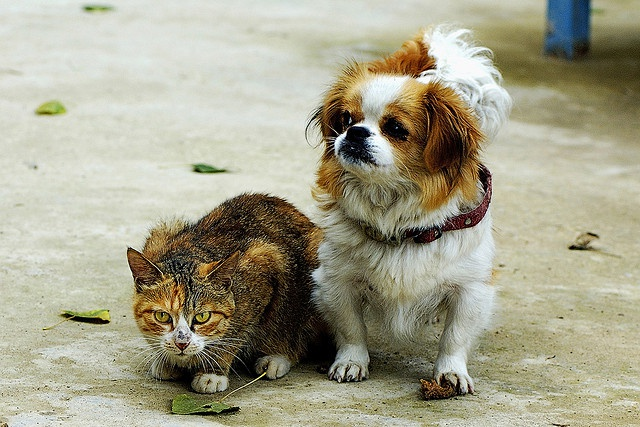Describe the objects in this image and their specific colors. I can see dog in lightgray, darkgray, black, and tan tones and cat in lightgray, black, olive, maroon, and tan tones in this image. 